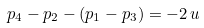<formula> <loc_0><loc_0><loc_500><loc_500>p _ { 4 } - p _ { 2 } - ( p _ { 1 } - p _ { 3 } ) = - 2 \, u</formula> 